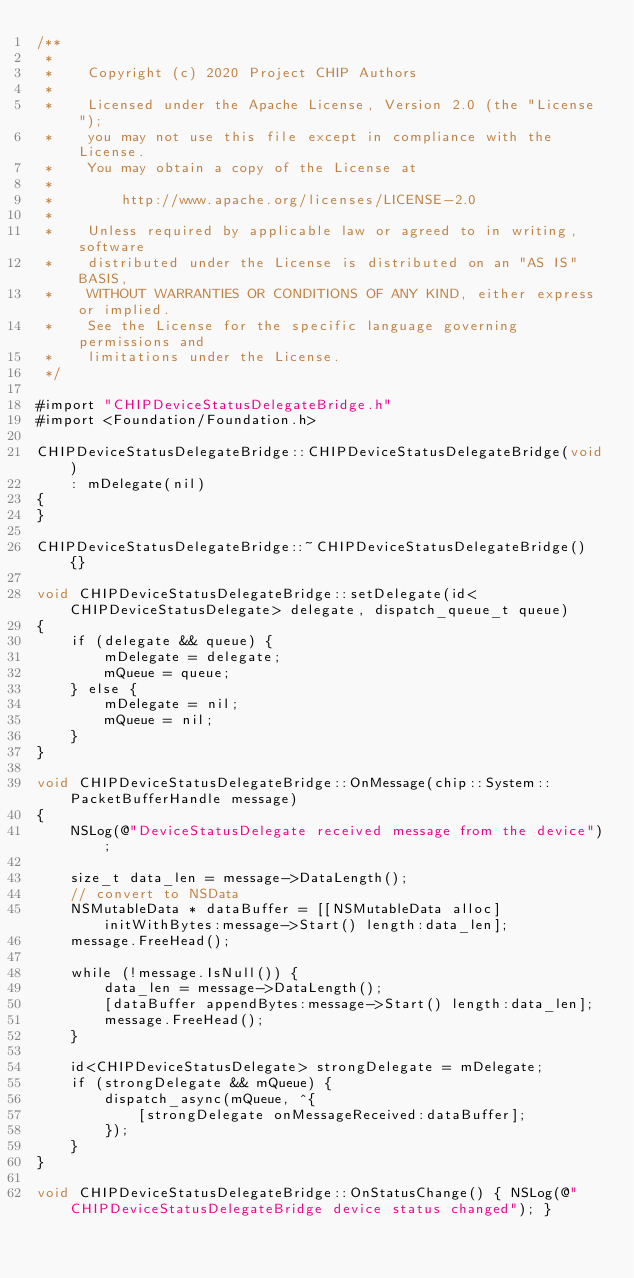Convert code to text. <code><loc_0><loc_0><loc_500><loc_500><_ObjectiveC_>/**
 *
 *    Copyright (c) 2020 Project CHIP Authors
 *
 *    Licensed under the Apache License, Version 2.0 (the "License");
 *    you may not use this file except in compliance with the License.
 *    You may obtain a copy of the License at
 *
 *        http://www.apache.org/licenses/LICENSE-2.0
 *
 *    Unless required by applicable law or agreed to in writing, software
 *    distributed under the License is distributed on an "AS IS" BASIS,
 *    WITHOUT WARRANTIES OR CONDITIONS OF ANY KIND, either express or implied.
 *    See the License for the specific language governing permissions and
 *    limitations under the License.
 */

#import "CHIPDeviceStatusDelegateBridge.h"
#import <Foundation/Foundation.h>

CHIPDeviceStatusDelegateBridge::CHIPDeviceStatusDelegateBridge(void)
    : mDelegate(nil)
{
}

CHIPDeviceStatusDelegateBridge::~CHIPDeviceStatusDelegateBridge() {}

void CHIPDeviceStatusDelegateBridge::setDelegate(id<CHIPDeviceStatusDelegate> delegate, dispatch_queue_t queue)
{
    if (delegate && queue) {
        mDelegate = delegate;
        mQueue = queue;
    } else {
        mDelegate = nil;
        mQueue = nil;
    }
}

void CHIPDeviceStatusDelegateBridge::OnMessage(chip::System::PacketBufferHandle message)
{
    NSLog(@"DeviceStatusDelegate received message from the device");

    size_t data_len = message->DataLength();
    // convert to NSData
    NSMutableData * dataBuffer = [[NSMutableData alloc] initWithBytes:message->Start() length:data_len];
    message.FreeHead();

    while (!message.IsNull()) {
        data_len = message->DataLength();
        [dataBuffer appendBytes:message->Start() length:data_len];
        message.FreeHead();
    }

    id<CHIPDeviceStatusDelegate> strongDelegate = mDelegate;
    if (strongDelegate && mQueue) {
        dispatch_async(mQueue, ^{
            [strongDelegate onMessageReceived:dataBuffer];
        });
    }
}

void CHIPDeviceStatusDelegateBridge::OnStatusChange() { NSLog(@"CHIPDeviceStatusDelegateBridge device status changed"); }
</code> 